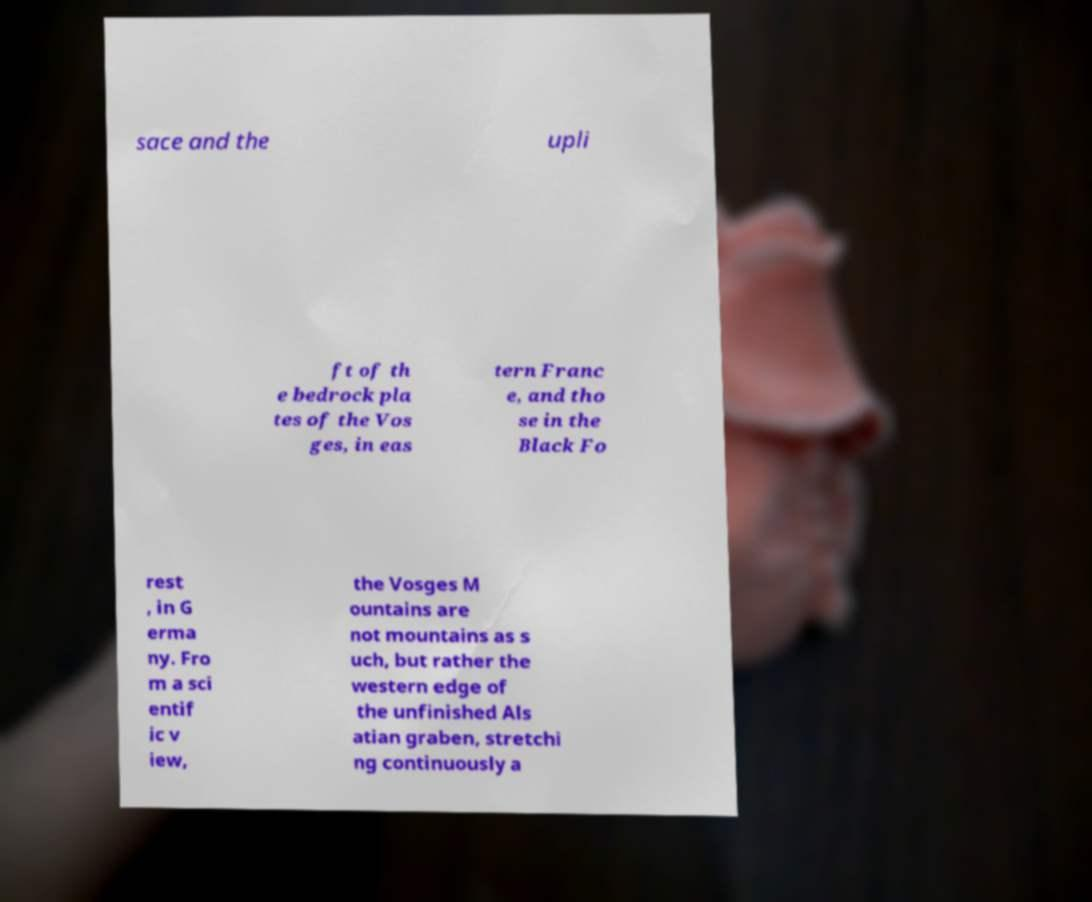Can you accurately transcribe the text from the provided image for me? sace and the upli ft of th e bedrock pla tes of the Vos ges, in eas tern Franc e, and tho se in the Black Fo rest , in G erma ny. Fro m a sci entif ic v iew, the Vosges M ountains are not mountains as s uch, but rather the western edge of the unfinished Als atian graben, stretchi ng continuously a 